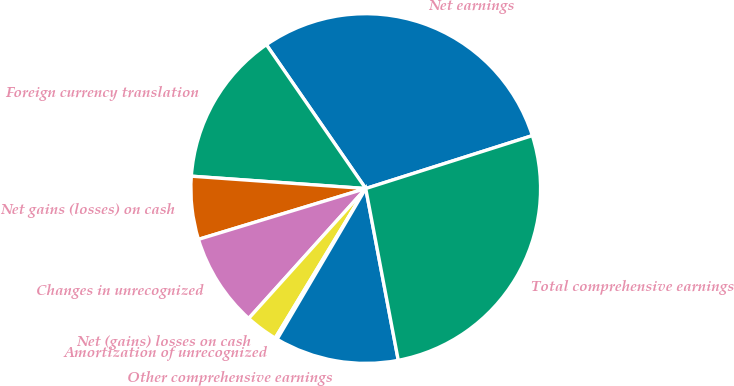Convert chart. <chart><loc_0><loc_0><loc_500><loc_500><pie_chart><fcel>Net earnings<fcel>Foreign currency translation<fcel>Net gains (losses) on cash<fcel>Changes in unrecognized<fcel>Net (gains) losses on cash<fcel>Amortization of unrecognized<fcel>Other comprehensive earnings<fcel>Total comprehensive earnings<nl><fcel>29.72%<fcel>14.25%<fcel>5.82%<fcel>8.63%<fcel>3.01%<fcel>0.2%<fcel>11.44%<fcel>26.91%<nl></chart> 